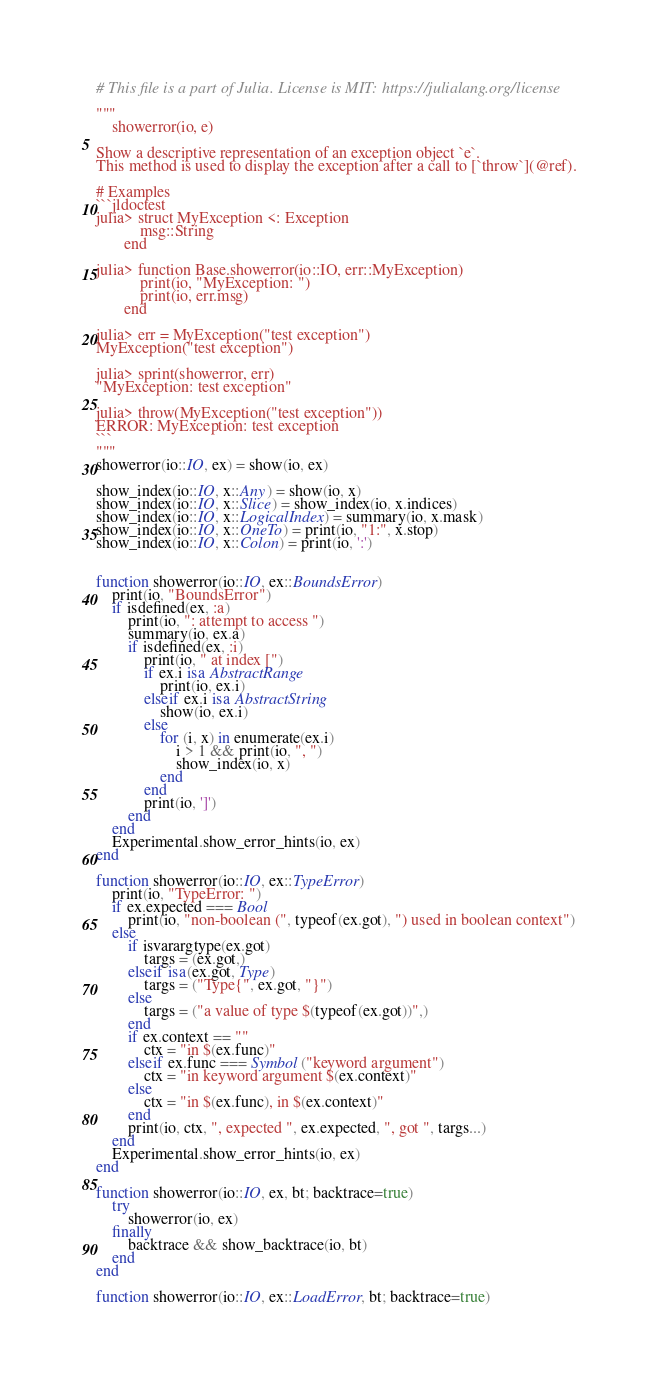Convert code to text. <code><loc_0><loc_0><loc_500><loc_500><_Julia_># This file is a part of Julia. License is MIT: https://julialang.org/license

"""
    showerror(io, e)

Show a descriptive representation of an exception object `e`.
This method is used to display the exception after a call to [`throw`](@ref).

# Examples
```jldoctest
julia> struct MyException <: Exception
           msg::String
       end

julia> function Base.showerror(io::IO, err::MyException)
           print(io, "MyException: ")
           print(io, err.msg)
       end

julia> err = MyException("test exception")
MyException("test exception")

julia> sprint(showerror, err)
"MyException: test exception"

julia> throw(MyException("test exception"))
ERROR: MyException: test exception
```
"""
showerror(io::IO, ex) = show(io, ex)

show_index(io::IO, x::Any) = show(io, x)
show_index(io::IO, x::Slice) = show_index(io, x.indices)
show_index(io::IO, x::LogicalIndex) = summary(io, x.mask)
show_index(io::IO, x::OneTo) = print(io, "1:", x.stop)
show_index(io::IO, x::Colon) = print(io, ':')


function showerror(io::IO, ex::BoundsError)
    print(io, "BoundsError")
    if isdefined(ex, :a)
        print(io, ": attempt to access ")
        summary(io, ex.a)
        if isdefined(ex, :i)
            print(io, " at index [")
            if ex.i isa AbstractRange
                print(io, ex.i)
            elseif ex.i isa AbstractString
                show(io, ex.i)
            else
                for (i, x) in enumerate(ex.i)
                    i > 1 && print(io, ", ")
                    show_index(io, x)
                end
            end
            print(io, ']')
        end
    end
    Experimental.show_error_hints(io, ex)
end

function showerror(io::IO, ex::TypeError)
    print(io, "TypeError: ")
    if ex.expected === Bool
        print(io, "non-boolean (", typeof(ex.got), ") used in boolean context")
    else
        if isvarargtype(ex.got)
            targs = (ex.got,)
        elseif isa(ex.got, Type)
            targs = ("Type{", ex.got, "}")
        else
            targs = ("a value of type $(typeof(ex.got))",)
        end
        if ex.context == ""
            ctx = "in $(ex.func)"
        elseif ex.func === Symbol("keyword argument")
            ctx = "in keyword argument $(ex.context)"
        else
            ctx = "in $(ex.func), in $(ex.context)"
        end
        print(io, ctx, ", expected ", ex.expected, ", got ", targs...)
    end
    Experimental.show_error_hints(io, ex)
end

function showerror(io::IO, ex, bt; backtrace=true)
    try
        showerror(io, ex)
    finally
        backtrace && show_backtrace(io, bt)
    end
end

function showerror(io::IO, ex::LoadError, bt; backtrace=true)</code> 